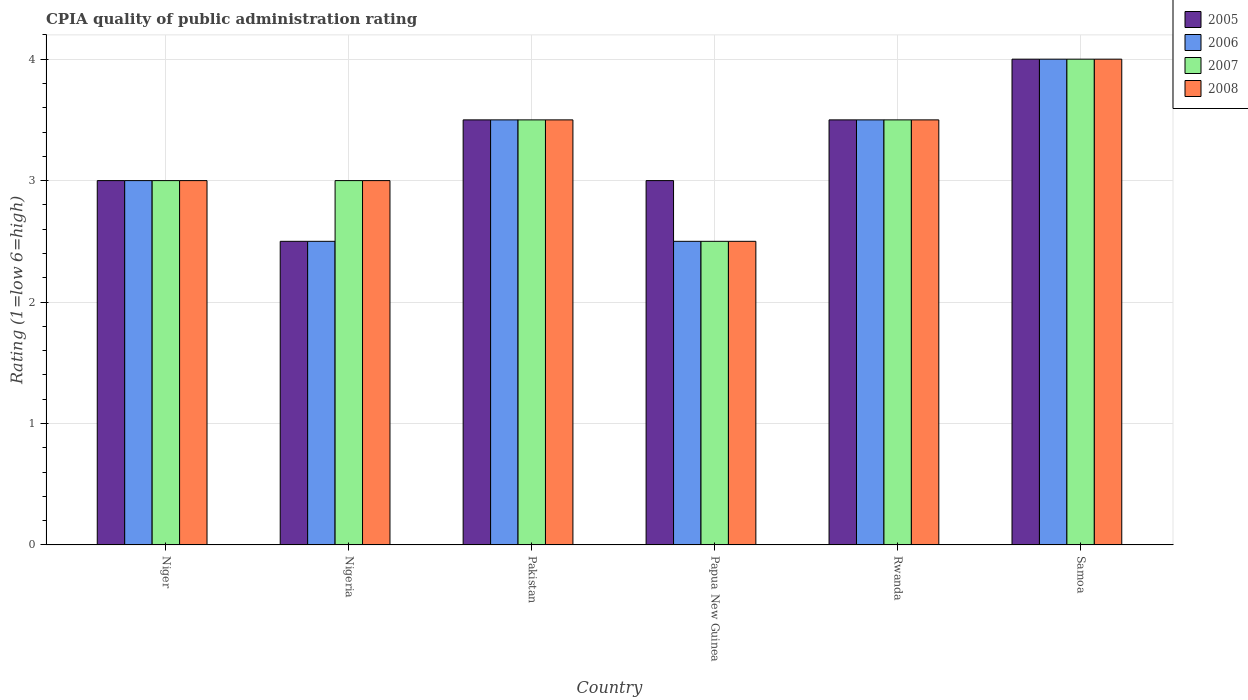How many groups of bars are there?
Keep it short and to the point. 6. Are the number of bars on each tick of the X-axis equal?
Give a very brief answer. Yes. How many bars are there on the 3rd tick from the left?
Provide a succinct answer. 4. What is the label of the 6th group of bars from the left?
Offer a very short reply. Samoa. In how many cases, is the number of bars for a given country not equal to the number of legend labels?
Ensure brevity in your answer.  0. Across all countries, what is the maximum CPIA rating in 2006?
Ensure brevity in your answer.  4. In which country was the CPIA rating in 2005 maximum?
Make the answer very short. Samoa. In which country was the CPIA rating in 2008 minimum?
Provide a succinct answer. Papua New Guinea. What is the difference between the CPIA rating in 2008 in Nigeria and the CPIA rating in 2006 in Pakistan?
Offer a very short reply. -0.5. What is the ratio of the CPIA rating in 2008 in Nigeria to that in Pakistan?
Offer a very short reply. 0.86. Is the CPIA rating in 2007 in Papua New Guinea less than that in Samoa?
Provide a succinct answer. Yes. Is the difference between the CPIA rating in 2005 in Pakistan and Rwanda greater than the difference between the CPIA rating in 2007 in Pakistan and Rwanda?
Ensure brevity in your answer.  No. Is the sum of the CPIA rating in 2005 in Nigeria and Pakistan greater than the maximum CPIA rating in 2006 across all countries?
Provide a short and direct response. Yes. Is it the case that in every country, the sum of the CPIA rating in 2005 and CPIA rating in 2007 is greater than the sum of CPIA rating in 2006 and CPIA rating in 2008?
Your answer should be compact. No. What does the 1st bar from the right in Rwanda represents?
Your answer should be compact. 2008. How many bars are there?
Ensure brevity in your answer.  24. Are all the bars in the graph horizontal?
Your response must be concise. No. How many countries are there in the graph?
Offer a very short reply. 6. What is the difference between two consecutive major ticks on the Y-axis?
Your answer should be very brief. 1. Are the values on the major ticks of Y-axis written in scientific E-notation?
Ensure brevity in your answer.  No. Does the graph contain any zero values?
Your answer should be very brief. No. Does the graph contain grids?
Ensure brevity in your answer.  Yes. Where does the legend appear in the graph?
Ensure brevity in your answer.  Top right. How are the legend labels stacked?
Your answer should be very brief. Vertical. What is the title of the graph?
Provide a short and direct response. CPIA quality of public administration rating. What is the Rating (1=low 6=high) in 2006 in Niger?
Offer a very short reply. 3. What is the Rating (1=low 6=high) of 2005 in Nigeria?
Provide a short and direct response. 2.5. What is the Rating (1=low 6=high) of 2007 in Nigeria?
Your answer should be compact. 3. What is the Rating (1=low 6=high) in 2005 in Pakistan?
Ensure brevity in your answer.  3.5. What is the Rating (1=low 6=high) of 2008 in Pakistan?
Give a very brief answer. 3.5. What is the Rating (1=low 6=high) of 2005 in Papua New Guinea?
Your answer should be compact. 3. What is the Rating (1=low 6=high) of 2007 in Papua New Guinea?
Your response must be concise. 2.5. What is the Rating (1=low 6=high) of 2005 in Rwanda?
Keep it short and to the point. 3.5. What is the Rating (1=low 6=high) of 2008 in Rwanda?
Keep it short and to the point. 3.5. What is the Rating (1=low 6=high) in 2005 in Samoa?
Offer a terse response. 4. What is the Rating (1=low 6=high) in 2006 in Samoa?
Your answer should be very brief. 4. What is the Rating (1=low 6=high) of 2007 in Samoa?
Offer a very short reply. 4. What is the Rating (1=low 6=high) in 2008 in Samoa?
Make the answer very short. 4. Across all countries, what is the maximum Rating (1=low 6=high) of 2005?
Make the answer very short. 4. Across all countries, what is the maximum Rating (1=low 6=high) in 2006?
Offer a very short reply. 4. Across all countries, what is the maximum Rating (1=low 6=high) of 2007?
Your answer should be very brief. 4. What is the total Rating (1=low 6=high) of 2006 in the graph?
Give a very brief answer. 19. What is the difference between the Rating (1=low 6=high) in 2006 in Niger and that in Nigeria?
Offer a very short reply. 0.5. What is the difference between the Rating (1=low 6=high) in 2006 in Niger and that in Pakistan?
Your answer should be compact. -0.5. What is the difference between the Rating (1=low 6=high) in 2008 in Niger and that in Pakistan?
Your response must be concise. -0.5. What is the difference between the Rating (1=low 6=high) in 2005 in Niger and that in Papua New Guinea?
Your answer should be compact. 0. What is the difference between the Rating (1=low 6=high) of 2005 in Niger and that in Rwanda?
Offer a very short reply. -0.5. What is the difference between the Rating (1=low 6=high) in 2006 in Niger and that in Rwanda?
Your answer should be very brief. -0.5. What is the difference between the Rating (1=low 6=high) in 2007 in Niger and that in Rwanda?
Your answer should be very brief. -0.5. What is the difference between the Rating (1=low 6=high) in 2005 in Niger and that in Samoa?
Your response must be concise. -1. What is the difference between the Rating (1=low 6=high) of 2007 in Niger and that in Samoa?
Offer a terse response. -1. What is the difference between the Rating (1=low 6=high) of 2005 in Nigeria and that in Pakistan?
Your answer should be compact. -1. What is the difference between the Rating (1=low 6=high) in 2007 in Nigeria and that in Pakistan?
Offer a terse response. -0.5. What is the difference between the Rating (1=low 6=high) in 2005 in Nigeria and that in Rwanda?
Ensure brevity in your answer.  -1. What is the difference between the Rating (1=low 6=high) in 2006 in Nigeria and that in Rwanda?
Your answer should be compact. -1. What is the difference between the Rating (1=low 6=high) of 2007 in Nigeria and that in Rwanda?
Give a very brief answer. -0.5. What is the difference between the Rating (1=low 6=high) of 2007 in Nigeria and that in Samoa?
Keep it short and to the point. -1. What is the difference between the Rating (1=low 6=high) in 2006 in Pakistan and that in Papua New Guinea?
Your answer should be very brief. 1. What is the difference between the Rating (1=low 6=high) of 2007 in Pakistan and that in Papua New Guinea?
Provide a succinct answer. 1. What is the difference between the Rating (1=low 6=high) of 2008 in Pakistan and that in Papua New Guinea?
Offer a very short reply. 1. What is the difference between the Rating (1=low 6=high) in 2005 in Pakistan and that in Samoa?
Your response must be concise. -0.5. What is the difference between the Rating (1=low 6=high) in 2008 in Pakistan and that in Samoa?
Your answer should be compact. -0.5. What is the difference between the Rating (1=low 6=high) in 2005 in Papua New Guinea and that in Rwanda?
Ensure brevity in your answer.  -0.5. What is the difference between the Rating (1=low 6=high) of 2006 in Papua New Guinea and that in Rwanda?
Your response must be concise. -1. What is the difference between the Rating (1=low 6=high) of 2005 in Papua New Guinea and that in Samoa?
Give a very brief answer. -1. What is the difference between the Rating (1=low 6=high) of 2007 in Papua New Guinea and that in Samoa?
Provide a short and direct response. -1.5. What is the difference between the Rating (1=low 6=high) of 2005 in Rwanda and that in Samoa?
Your response must be concise. -0.5. What is the difference between the Rating (1=low 6=high) of 2006 in Rwanda and that in Samoa?
Give a very brief answer. -0.5. What is the difference between the Rating (1=low 6=high) in 2007 in Rwanda and that in Samoa?
Your answer should be very brief. -0.5. What is the difference between the Rating (1=low 6=high) in 2008 in Rwanda and that in Samoa?
Make the answer very short. -0.5. What is the difference between the Rating (1=low 6=high) of 2005 in Niger and the Rating (1=low 6=high) of 2006 in Nigeria?
Give a very brief answer. 0.5. What is the difference between the Rating (1=low 6=high) of 2005 in Niger and the Rating (1=low 6=high) of 2007 in Nigeria?
Make the answer very short. 0. What is the difference between the Rating (1=low 6=high) in 2006 in Niger and the Rating (1=low 6=high) in 2008 in Nigeria?
Make the answer very short. 0. What is the difference between the Rating (1=low 6=high) in 2007 in Niger and the Rating (1=low 6=high) in 2008 in Nigeria?
Provide a succinct answer. 0. What is the difference between the Rating (1=low 6=high) of 2005 in Niger and the Rating (1=low 6=high) of 2006 in Pakistan?
Ensure brevity in your answer.  -0.5. What is the difference between the Rating (1=low 6=high) of 2006 in Niger and the Rating (1=low 6=high) of 2008 in Pakistan?
Offer a terse response. -0.5. What is the difference between the Rating (1=low 6=high) of 2007 in Niger and the Rating (1=low 6=high) of 2008 in Pakistan?
Give a very brief answer. -0.5. What is the difference between the Rating (1=low 6=high) of 2007 in Niger and the Rating (1=low 6=high) of 2008 in Papua New Guinea?
Your answer should be very brief. 0.5. What is the difference between the Rating (1=low 6=high) in 2005 in Niger and the Rating (1=low 6=high) in 2006 in Rwanda?
Keep it short and to the point. -0.5. What is the difference between the Rating (1=low 6=high) in 2005 in Niger and the Rating (1=low 6=high) in 2007 in Rwanda?
Provide a short and direct response. -0.5. What is the difference between the Rating (1=low 6=high) in 2005 in Niger and the Rating (1=low 6=high) in 2008 in Rwanda?
Make the answer very short. -0.5. What is the difference between the Rating (1=low 6=high) of 2005 in Niger and the Rating (1=low 6=high) of 2008 in Samoa?
Offer a terse response. -1. What is the difference between the Rating (1=low 6=high) in 2005 in Nigeria and the Rating (1=low 6=high) in 2006 in Pakistan?
Provide a short and direct response. -1. What is the difference between the Rating (1=low 6=high) of 2005 in Nigeria and the Rating (1=low 6=high) of 2007 in Pakistan?
Provide a succinct answer. -1. What is the difference between the Rating (1=low 6=high) in 2005 in Nigeria and the Rating (1=low 6=high) in 2008 in Pakistan?
Your answer should be compact. -1. What is the difference between the Rating (1=low 6=high) of 2006 in Nigeria and the Rating (1=low 6=high) of 2008 in Pakistan?
Ensure brevity in your answer.  -1. What is the difference between the Rating (1=low 6=high) in 2005 in Nigeria and the Rating (1=low 6=high) in 2007 in Papua New Guinea?
Keep it short and to the point. 0. What is the difference between the Rating (1=low 6=high) in 2005 in Nigeria and the Rating (1=low 6=high) in 2008 in Papua New Guinea?
Ensure brevity in your answer.  0. What is the difference between the Rating (1=low 6=high) of 2006 in Nigeria and the Rating (1=low 6=high) of 2008 in Papua New Guinea?
Provide a short and direct response. 0. What is the difference between the Rating (1=low 6=high) of 2005 in Nigeria and the Rating (1=low 6=high) of 2007 in Rwanda?
Your answer should be very brief. -1. What is the difference between the Rating (1=low 6=high) of 2005 in Nigeria and the Rating (1=low 6=high) of 2008 in Rwanda?
Provide a succinct answer. -1. What is the difference between the Rating (1=low 6=high) of 2006 in Nigeria and the Rating (1=low 6=high) of 2008 in Rwanda?
Your answer should be compact. -1. What is the difference between the Rating (1=low 6=high) of 2005 in Nigeria and the Rating (1=low 6=high) of 2006 in Samoa?
Make the answer very short. -1.5. What is the difference between the Rating (1=low 6=high) in 2005 in Nigeria and the Rating (1=low 6=high) in 2007 in Samoa?
Your answer should be very brief. -1.5. What is the difference between the Rating (1=low 6=high) in 2005 in Nigeria and the Rating (1=low 6=high) in 2008 in Samoa?
Ensure brevity in your answer.  -1.5. What is the difference between the Rating (1=low 6=high) in 2006 in Nigeria and the Rating (1=low 6=high) in 2007 in Samoa?
Keep it short and to the point. -1.5. What is the difference between the Rating (1=low 6=high) in 2005 in Pakistan and the Rating (1=low 6=high) in 2007 in Papua New Guinea?
Your response must be concise. 1. What is the difference between the Rating (1=low 6=high) in 2005 in Pakistan and the Rating (1=low 6=high) in 2008 in Papua New Guinea?
Your response must be concise. 1. What is the difference between the Rating (1=low 6=high) of 2006 in Pakistan and the Rating (1=low 6=high) of 2008 in Papua New Guinea?
Keep it short and to the point. 1. What is the difference between the Rating (1=low 6=high) of 2007 in Pakistan and the Rating (1=low 6=high) of 2008 in Papua New Guinea?
Your response must be concise. 1. What is the difference between the Rating (1=low 6=high) of 2005 in Pakistan and the Rating (1=low 6=high) of 2007 in Rwanda?
Provide a succinct answer. 0. What is the difference between the Rating (1=low 6=high) in 2005 in Pakistan and the Rating (1=low 6=high) in 2008 in Rwanda?
Make the answer very short. 0. What is the difference between the Rating (1=low 6=high) of 2006 in Pakistan and the Rating (1=low 6=high) of 2007 in Rwanda?
Your answer should be very brief. 0. What is the difference between the Rating (1=low 6=high) in 2005 in Pakistan and the Rating (1=low 6=high) in 2006 in Samoa?
Keep it short and to the point. -0.5. What is the difference between the Rating (1=low 6=high) of 2005 in Pakistan and the Rating (1=low 6=high) of 2007 in Samoa?
Offer a terse response. -0.5. What is the difference between the Rating (1=low 6=high) of 2006 in Pakistan and the Rating (1=low 6=high) of 2008 in Samoa?
Offer a terse response. -0.5. What is the difference between the Rating (1=low 6=high) of 2005 in Papua New Guinea and the Rating (1=low 6=high) of 2008 in Rwanda?
Your response must be concise. -0.5. What is the difference between the Rating (1=low 6=high) of 2006 in Papua New Guinea and the Rating (1=low 6=high) of 2008 in Rwanda?
Your answer should be compact. -1. What is the difference between the Rating (1=low 6=high) of 2005 in Papua New Guinea and the Rating (1=low 6=high) of 2006 in Samoa?
Offer a terse response. -1. What is the difference between the Rating (1=low 6=high) in 2005 in Papua New Guinea and the Rating (1=low 6=high) in 2007 in Samoa?
Your answer should be compact. -1. What is the difference between the Rating (1=low 6=high) of 2005 in Papua New Guinea and the Rating (1=low 6=high) of 2008 in Samoa?
Your answer should be compact. -1. What is the difference between the Rating (1=low 6=high) in 2006 in Papua New Guinea and the Rating (1=low 6=high) in 2007 in Samoa?
Offer a terse response. -1.5. What is the difference between the Rating (1=low 6=high) in 2007 in Papua New Guinea and the Rating (1=low 6=high) in 2008 in Samoa?
Offer a terse response. -1.5. What is the difference between the Rating (1=low 6=high) of 2005 in Rwanda and the Rating (1=low 6=high) of 2008 in Samoa?
Give a very brief answer. -0.5. What is the difference between the Rating (1=low 6=high) in 2007 in Rwanda and the Rating (1=low 6=high) in 2008 in Samoa?
Make the answer very short. -0.5. What is the average Rating (1=low 6=high) of 2006 per country?
Provide a succinct answer. 3.17. What is the difference between the Rating (1=low 6=high) in 2005 and Rating (1=low 6=high) in 2006 in Niger?
Ensure brevity in your answer.  0. What is the difference between the Rating (1=low 6=high) of 2005 and Rating (1=low 6=high) of 2007 in Niger?
Provide a succinct answer. 0. What is the difference between the Rating (1=low 6=high) of 2007 and Rating (1=low 6=high) of 2008 in Niger?
Give a very brief answer. 0. What is the difference between the Rating (1=low 6=high) in 2005 and Rating (1=low 6=high) in 2007 in Nigeria?
Your response must be concise. -0.5. What is the difference between the Rating (1=low 6=high) in 2005 and Rating (1=low 6=high) in 2008 in Nigeria?
Your answer should be very brief. -0.5. What is the difference between the Rating (1=low 6=high) in 2006 and Rating (1=low 6=high) in 2008 in Nigeria?
Provide a succinct answer. -0.5. What is the difference between the Rating (1=low 6=high) of 2005 and Rating (1=low 6=high) of 2006 in Pakistan?
Ensure brevity in your answer.  0. What is the difference between the Rating (1=low 6=high) in 2005 and Rating (1=low 6=high) in 2007 in Pakistan?
Offer a very short reply. 0. What is the difference between the Rating (1=low 6=high) in 2005 and Rating (1=low 6=high) in 2008 in Pakistan?
Provide a succinct answer. 0. What is the difference between the Rating (1=low 6=high) of 2006 and Rating (1=low 6=high) of 2007 in Pakistan?
Provide a succinct answer. 0. What is the difference between the Rating (1=low 6=high) of 2006 and Rating (1=low 6=high) of 2008 in Pakistan?
Your response must be concise. 0. What is the difference between the Rating (1=low 6=high) of 2007 and Rating (1=low 6=high) of 2008 in Pakistan?
Provide a succinct answer. 0. What is the difference between the Rating (1=low 6=high) of 2005 and Rating (1=low 6=high) of 2006 in Papua New Guinea?
Offer a terse response. 0.5. What is the difference between the Rating (1=low 6=high) in 2006 and Rating (1=low 6=high) in 2007 in Papua New Guinea?
Make the answer very short. 0. What is the difference between the Rating (1=low 6=high) in 2006 and Rating (1=low 6=high) in 2008 in Papua New Guinea?
Provide a succinct answer. 0. What is the difference between the Rating (1=low 6=high) in 2007 and Rating (1=low 6=high) in 2008 in Papua New Guinea?
Keep it short and to the point. 0. What is the difference between the Rating (1=low 6=high) in 2005 and Rating (1=low 6=high) in 2006 in Rwanda?
Offer a very short reply. 0. What is the difference between the Rating (1=low 6=high) in 2005 and Rating (1=low 6=high) in 2007 in Rwanda?
Your answer should be compact. 0. What is the difference between the Rating (1=low 6=high) in 2005 and Rating (1=low 6=high) in 2008 in Rwanda?
Your response must be concise. 0. What is the difference between the Rating (1=low 6=high) of 2006 and Rating (1=low 6=high) of 2008 in Rwanda?
Give a very brief answer. 0. What is the difference between the Rating (1=low 6=high) of 2007 and Rating (1=low 6=high) of 2008 in Rwanda?
Your response must be concise. 0. What is the difference between the Rating (1=low 6=high) in 2005 and Rating (1=low 6=high) in 2006 in Samoa?
Your response must be concise. 0. What is the difference between the Rating (1=low 6=high) of 2005 and Rating (1=low 6=high) of 2007 in Samoa?
Your response must be concise. 0. What is the difference between the Rating (1=low 6=high) of 2006 and Rating (1=low 6=high) of 2007 in Samoa?
Ensure brevity in your answer.  0. What is the difference between the Rating (1=low 6=high) in 2007 and Rating (1=low 6=high) in 2008 in Samoa?
Provide a succinct answer. 0. What is the ratio of the Rating (1=low 6=high) of 2005 in Niger to that in Pakistan?
Your response must be concise. 0.86. What is the ratio of the Rating (1=low 6=high) in 2006 in Niger to that in Pakistan?
Make the answer very short. 0.86. What is the ratio of the Rating (1=low 6=high) of 2007 in Niger to that in Pakistan?
Your response must be concise. 0.86. What is the ratio of the Rating (1=low 6=high) of 2006 in Niger to that in Papua New Guinea?
Your answer should be compact. 1.2. What is the ratio of the Rating (1=low 6=high) in 2007 in Niger to that in Rwanda?
Make the answer very short. 0.86. What is the ratio of the Rating (1=low 6=high) in 2005 in Niger to that in Samoa?
Offer a very short reply. 0.75. What is the ratio of the Rating (1=low 6=high) of 2007 in Niger to that in Samoa?
Provide a short and direct response. 0.75. What is the ratio of the Rating (1=low 6=high) of 2007 in Nigeria to that in Pakistan?
Ensure brevity in your answer.  0.86. What is the ratio of the Rating (1=low 6=high) of 2008 in Nigeria to that in Pakistan?
Your response must be concise. 0.86. What is the ratio of the Rating (1=low 6=high) of 2005 in Nigeria to that in Papua New Guinea?
Make the answer very short. 0.83. What is the ratio of the Rating (1=low 6=high) of 2008 in Nigeria to that in Papua New Guinea?
Provide a short and direct response. 1.2. What is the ratio of the Rating (1=low 6=high) of 2006 in Nigeria to that in Rwanda?
Your response must be concise. 0.71. What is the ratio of the Rating (1=low 6=high) in 2005 in Nigeria to that in Samoa?
Your response must be concise. 0.62. What is the ratio of the Rating (1=low 6=high) in 2007 in Nigeria to that in Samoa?
Ensure brevity in your answer.  0.75. What is the ratio of the Rating (1=low 6=high) of 2006 in Pakistan to that in Papua New Guinea?
Your answer should be very brief. 1.4. What is the ratio of the Rating (1=low 6=high) in 2008 in Pakistan to that in Rwanda?
Keep it short and to the point. 1. What is the ratio of the Rating (1=low 6=high) of 2006 in Pakistan to that in Samoa?
Offer a very short reply. 0.88. What is the ratio of the Rating (1=low 6=high) in 2008 in Pakistan to that in Samoa?
Ensure brevity in your answer.  0.88. What is the ratio of the Rating (1=low 6=high) of 2007 in Papua New Guinea to that in Rwanda?
Your answer should be very brief. 0.71. What is the ratio of the Rating (1=low 6=high) of 2008 in Papua New Guinea to that in Rwanda?
Your answer should be very brief. 0.71. What is the ratio of the Rating (1=low 6=high) of 2005 in Papua New Guinea to that in Samoa?
Keep it short and to the point. 0.75. What is the ratio of the Rating (1=low 6=high) in 2006 in Papua New Guinea to that in Samoa?
Give a very brief answer. 0.62. What is the ratio of the Rating (1=low 6=high) in 2008 in Rwanda to that in Samoa?
Your answer should be very brief. 0.88. What is the difference between the highest and the second highest Rating (1=low 6=high) in 2005?
Provide a short and direct response. 0.5. 